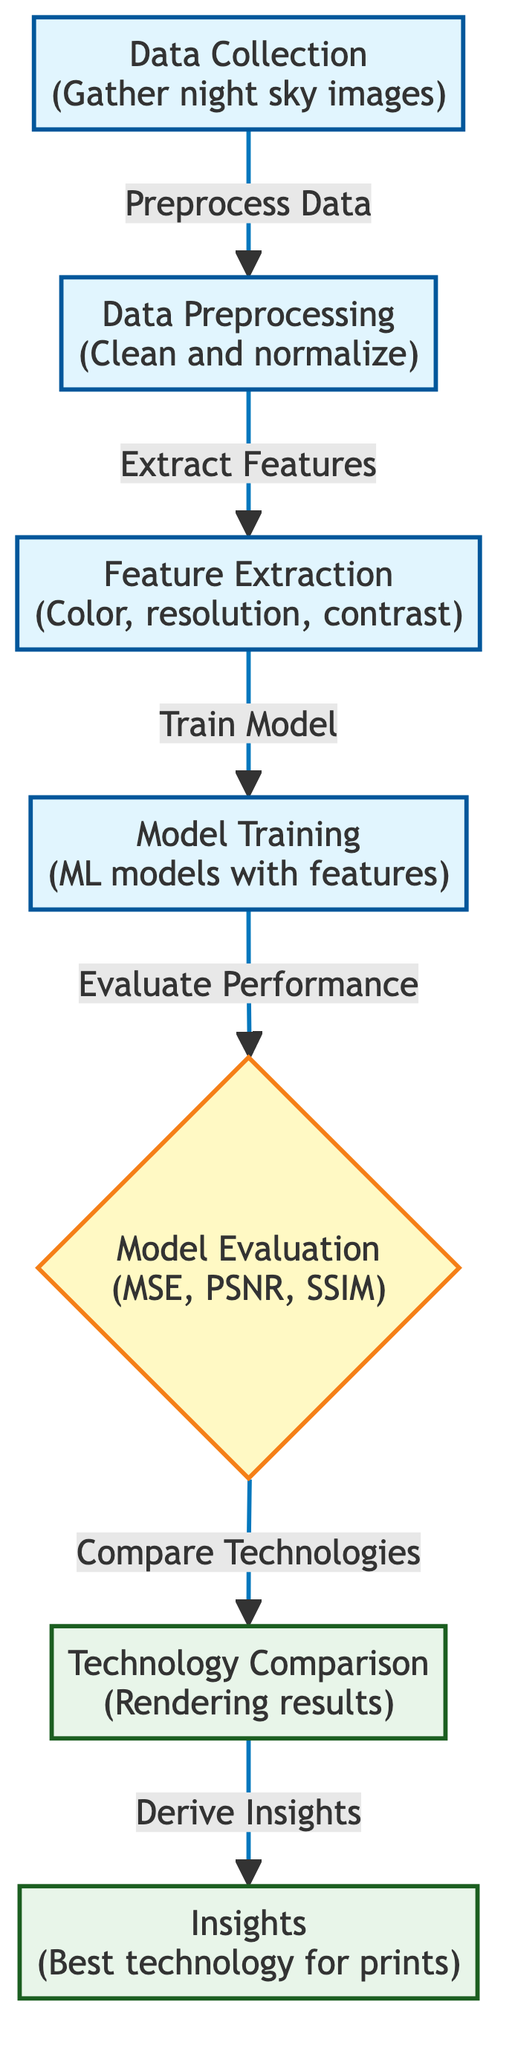What is the first step in the diagram? The first step in the diagram is labeled as "Data Collection" which involves gathering night sky images. This is the starting node and is essential for the subsequent processes.
Answer: Data Collection How many evaluation metrics are shown in the diagram? The evaluation node mentions three metrics: MSE, PSNR, and SSIM. By counting the terms listed, we can determine that there are three metrics.
Answer: Three What comes after feature extraction? According to the flow of the diagram, after "Feature Extraction," the next step is "Model Training." This indicates that once features are extracted, the next logical process is to train the model with those features.
Answer: Model Training Which process follows the evaluation step? After "Model Evaluation," the subsequent process in the diagram is "Technology Comparison." This indicates that once the models are evaluated, the next step is to compare different technologies based on the rendered results.
Answer: Technology Comparison What do the output nodes represent? The output nodes represent the final results of the analysis, specifically "Rendering results" from technology comparison and "Best technology for prints" from insights generation. These show the conclusions derived from the previous steps.
Answer: Rendering results and Best technology for prints How many processes are there in total in this diagram? There are five distinct process nodes in the diagram: "Data Collection," "Data Preprocessing," "Feature Extraction," "Model Training," and "Evaluation." Therefore, by counting these specific nodes, we find a total of five.
Answer: Five What is the decision process in the diagram? The decision process in the diagram is labeled as "Model Evaluation," which uses metrics like MSE, PSNR, and SSIM to make evaluative decisions on the model's performance. This step determines how well the model is doing before comparison.
Answer: Model Evaluation What does the "Insights" node provide? The "Insights" node provides the concluding findings regarding the best technology for rendering nocturnal landscape prints based on the evaluations of various printing technologies. It summarizes the analysis of the previous processes.
Answer: Best technology for prints 